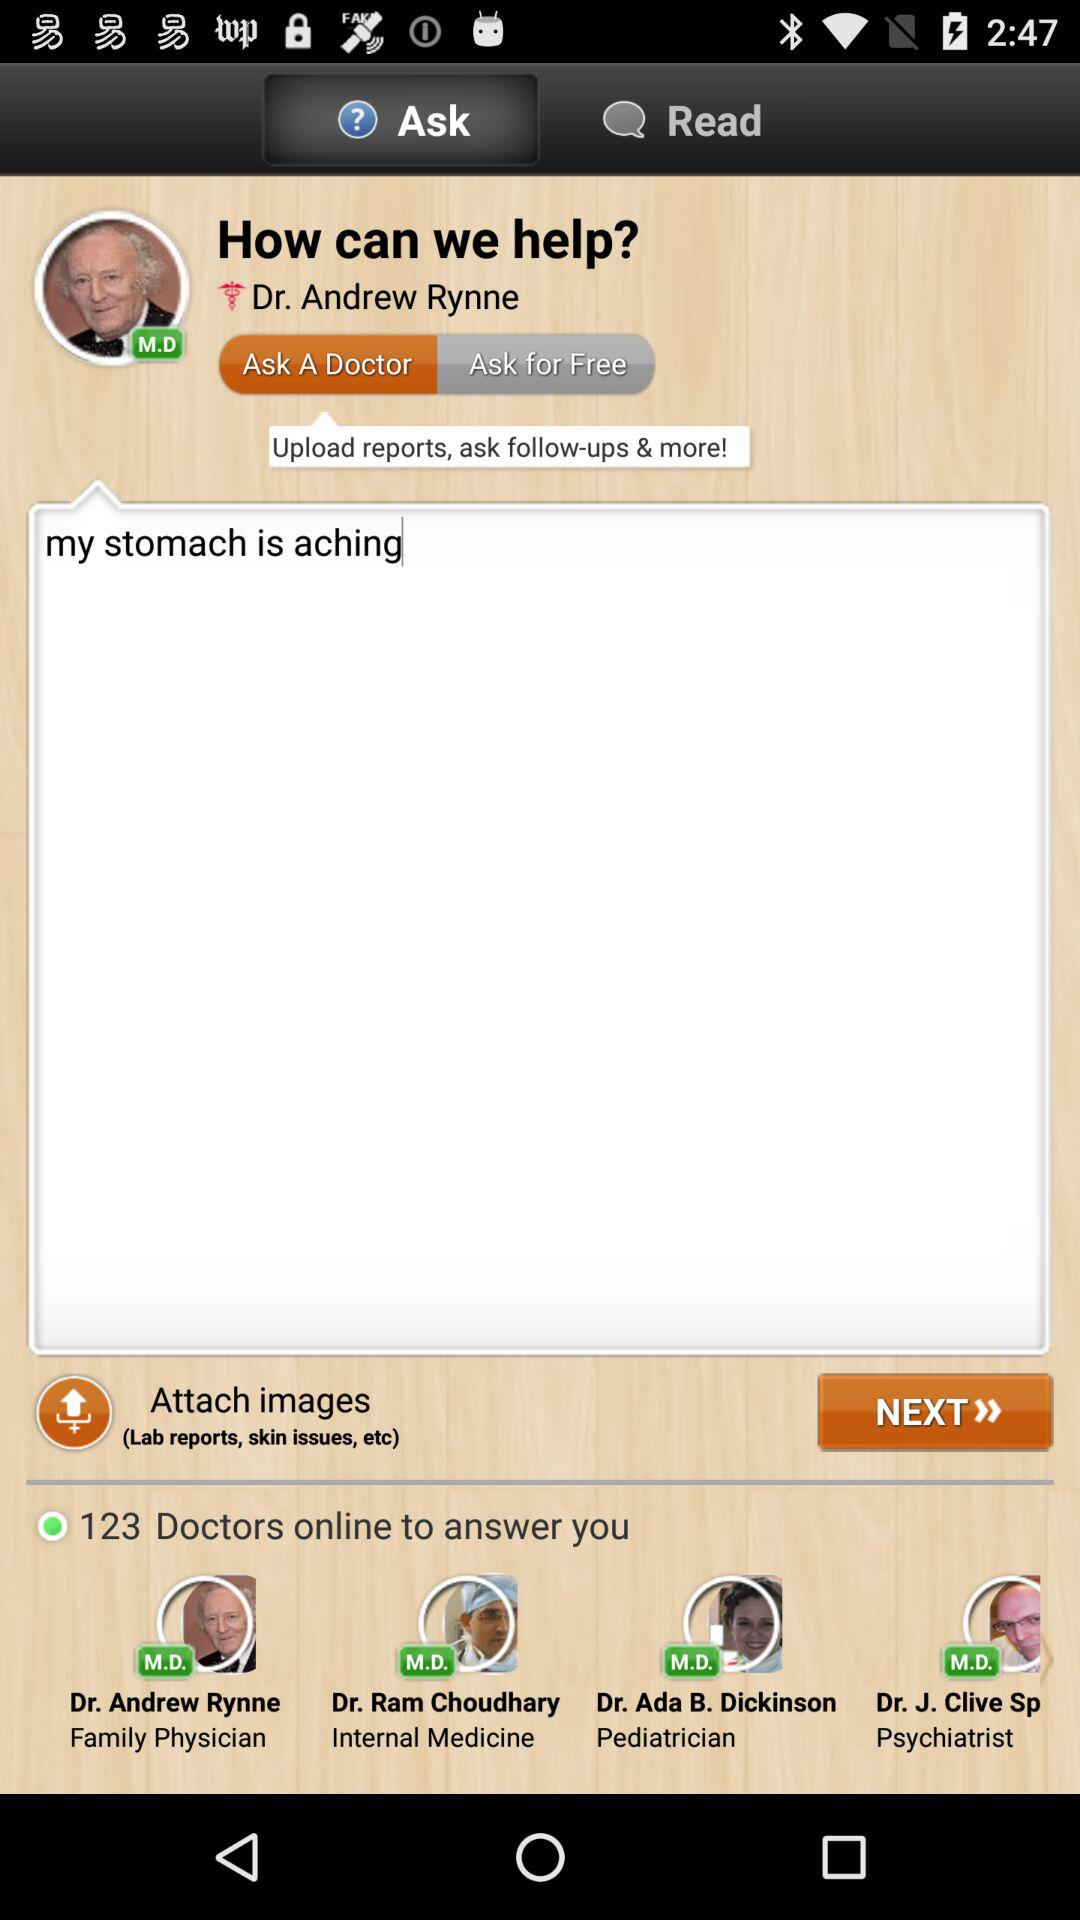How many doctors are available to answer a question?
Answer the question using a single word or phrase. 123 